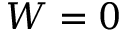<formula> <loc_0><loc_0><loc_500><loc_500>W = 0</formula> 